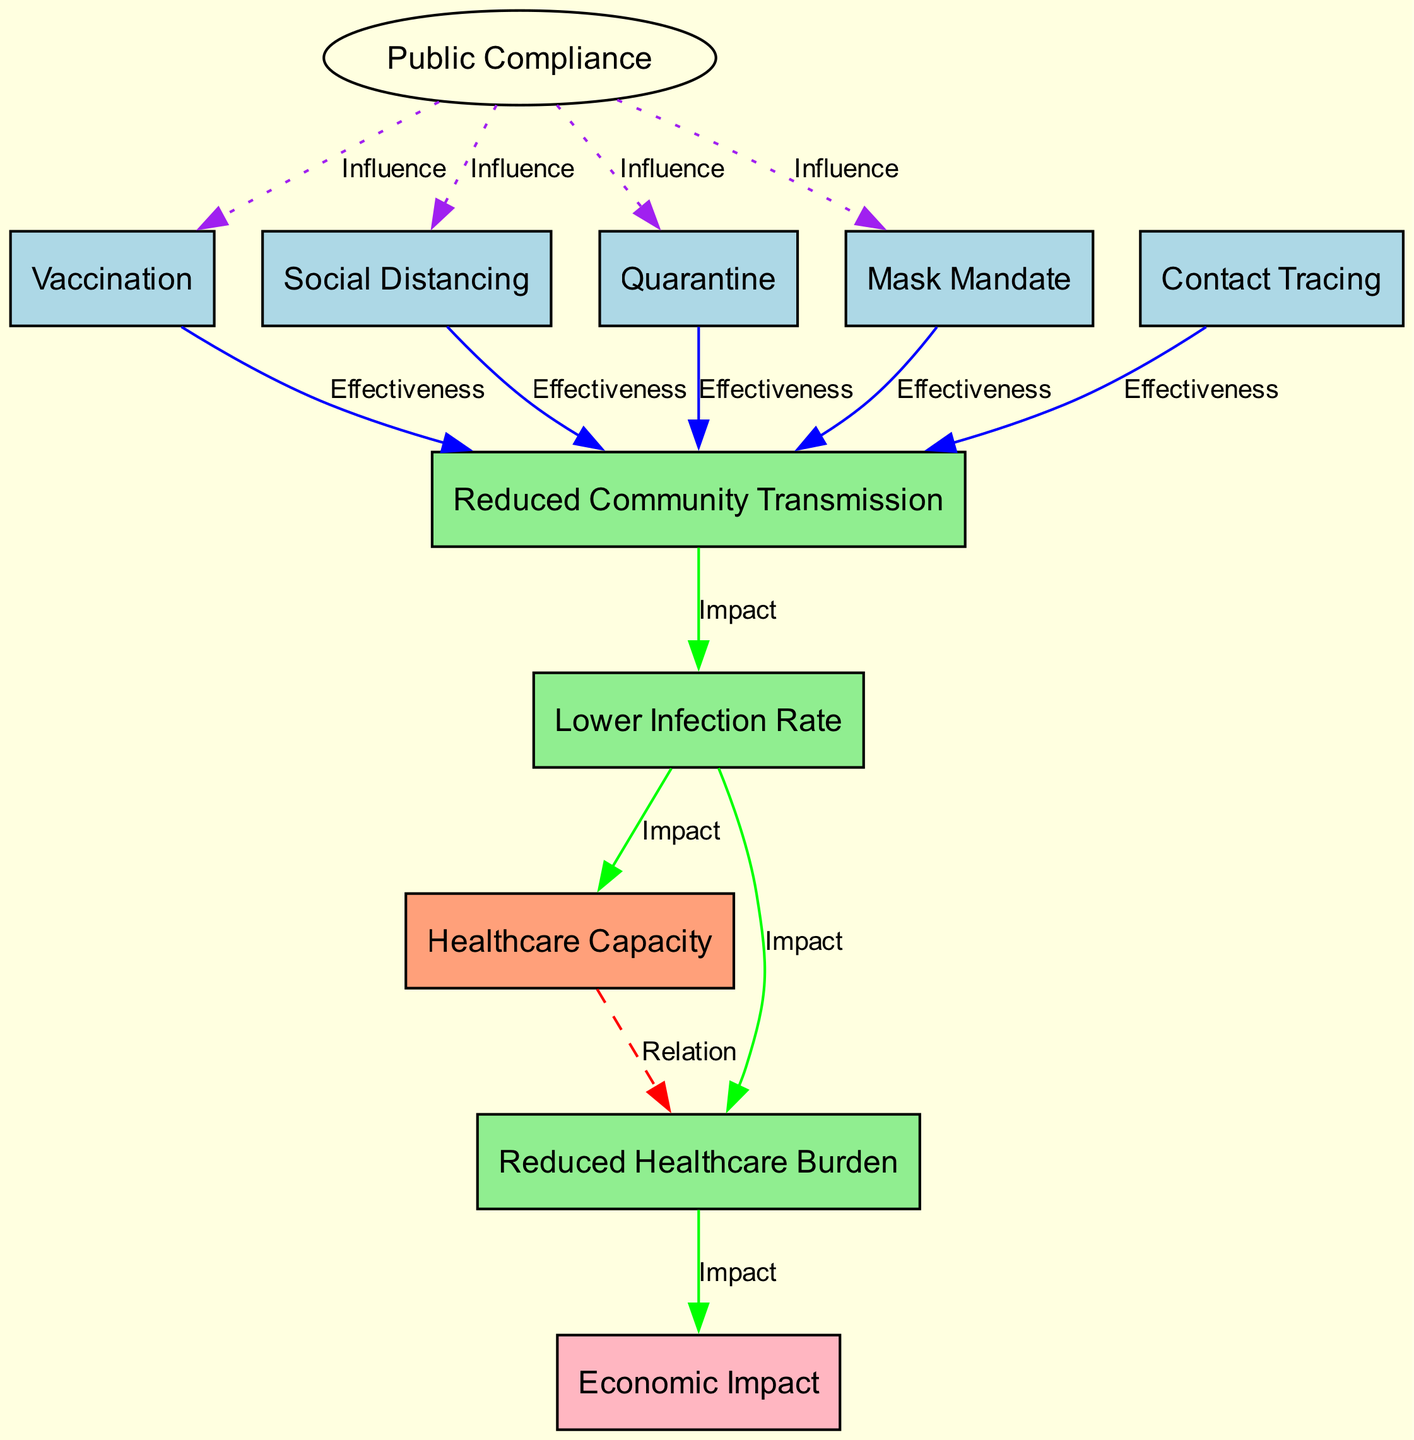What is the total number of nodes in the diagram? The total number of nodes can be counted from the provided data. There are 11 nodes listed: Vaccination, Social Distancing, Quarantine, Mask Mandate, Contact Tracing, Healthcare Capacity, Reduced Community Transmission, Lower Infection Rate, Reduced Healthcare Burden, Economic Impact, and Public Compliance.
Answer: 11 Which intervention connects directly to Reduced Community Transmission? From the edges listed in the data, Vaccination, Social Distancing, Quarantine, Mask Mandate, and Contact Tracing all connect to Reduced Community Transmission.
Answer: Vaccination, Social Distancing, Quarantine, Mask Mandate, Contact Tracing What colors represent the health interventions in the diagram? The health interventions (Vaccination, Social Distancing, Quarantine, Mask Mandate, Contact Tracing) are represented with the color light blue as specified in the node color assignments.
Answer: Light blue What is the relationship between Healthcare Capacity and Healthcare Burden? The relationship is indicated by a dashed red line connecting these two nodes, labeled as 'Relation' in the edges section of the data.
Answer: Relation How many influences does Public Compliance have on other interventions? Public Compliance influences four interventions: Social Distancing, Mask Mandate, Vaccination, and Quarantine. Counting these gives the total influence as four.
Answer: 4 Which intervention has the most direct connections to other nodes? By analyzing the edges, it is found that both Public Compliance and Reduced Community Transmission connect to multiple other nodes. Public Compliance influences four nodes, and Reduced Community Transmission connects to three additional nodes, indicating that Public Compliance has the most direct connections overall.
Answer: Public Compliance What is the impact of Lower Infection Rate on Healthcare Capacity? The edge data shows that Lower Infection Rate directly affects Healthcare Capacity by indicating that a lower Infection Rate causes a change in Healthcare Capacity, hence it is an impact relationship.
Answer: Impact What type of edge connects Public Compliance to Social Distancing? According to the edge definitions, the connection from Public Compliance to Social Distancing is labeled as 'Influence', which is represented by a dotted purple line.
Answer: Influence 